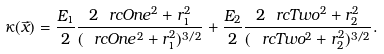<formula> <loc_0><loc_0><loc_500><loc_500>\kappa ( \vec { x } ) = \frac { E _ { 1 } } { 2 } \frac { 2 \ r c O n e ^ { 2 } + r _ { 1 } ^ { 2 } } { ( \ r c O n e ^ { 2 } + r _ { 1 } ^ { 2 } ) ^ { 3 / 2 } } + \frac { E _ { 2 } } { 2 } \frac { 2 \ r c T w o ^ { 2 } + r _ { 2 } ^ { 2 } } { ( \ r c T w o ^ { 2 } + r _ { 2 } ^ { 2 } ) ^ { 3 / 2 } } .</formula> 